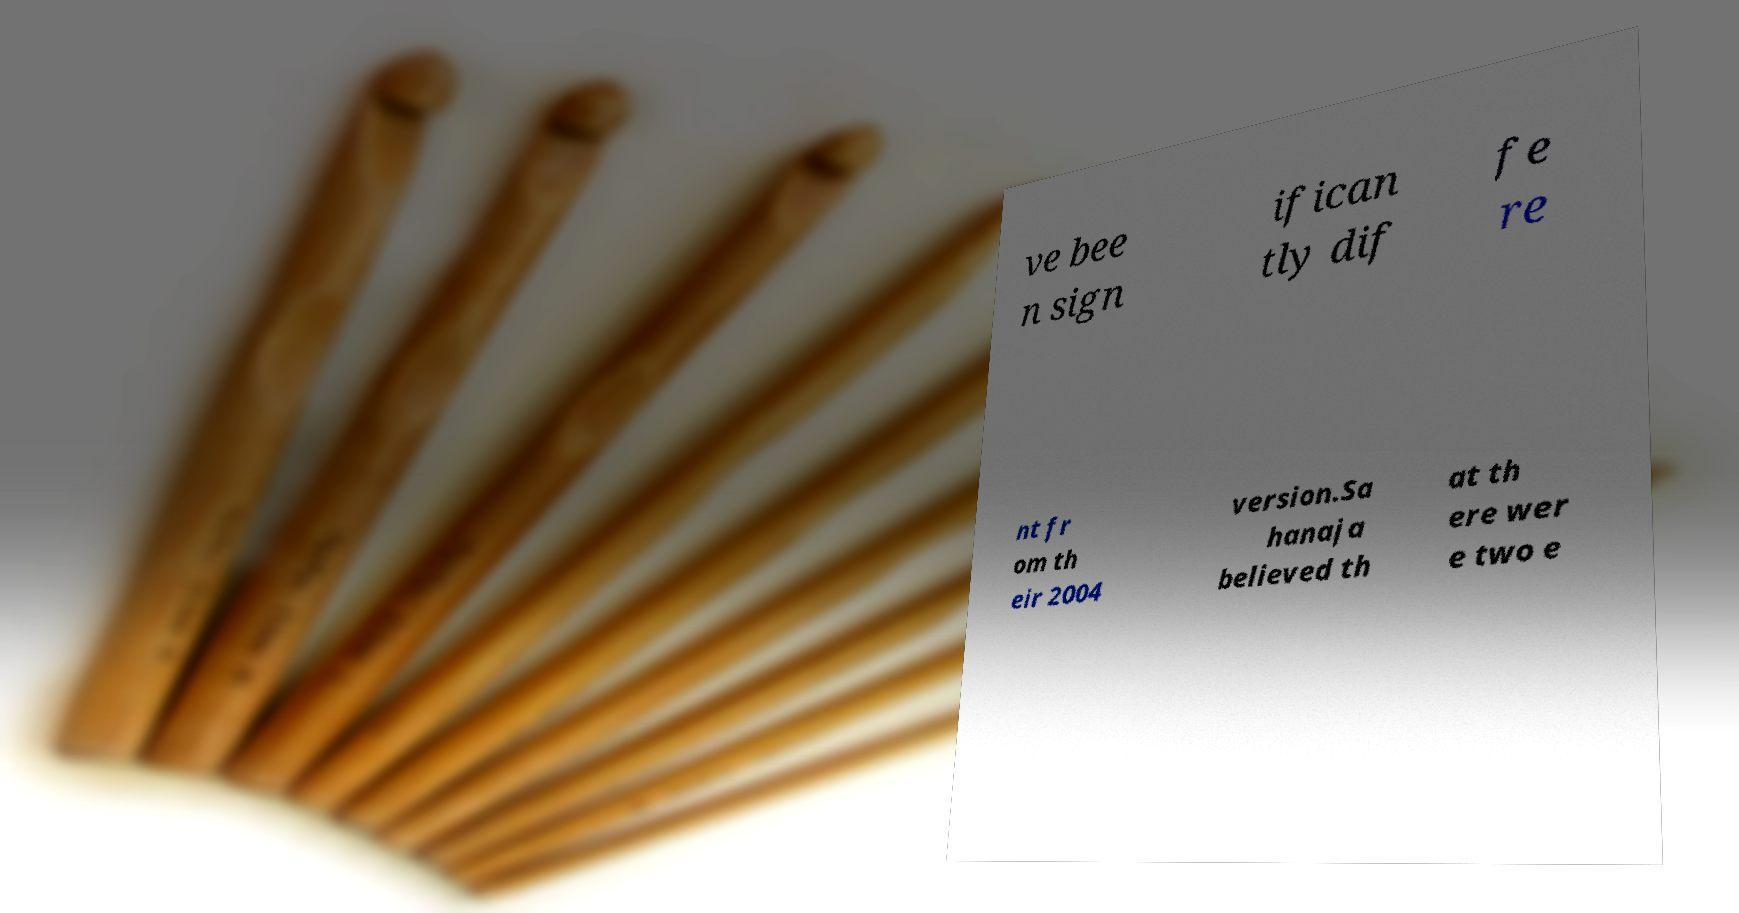What messages or text are displayed in this image? I need them in a readable, typed format. ve bee n sign ifican tly dif fe re nt fr om th eir 2004 version.Sa hanaja believed th at th ere wer e two e 